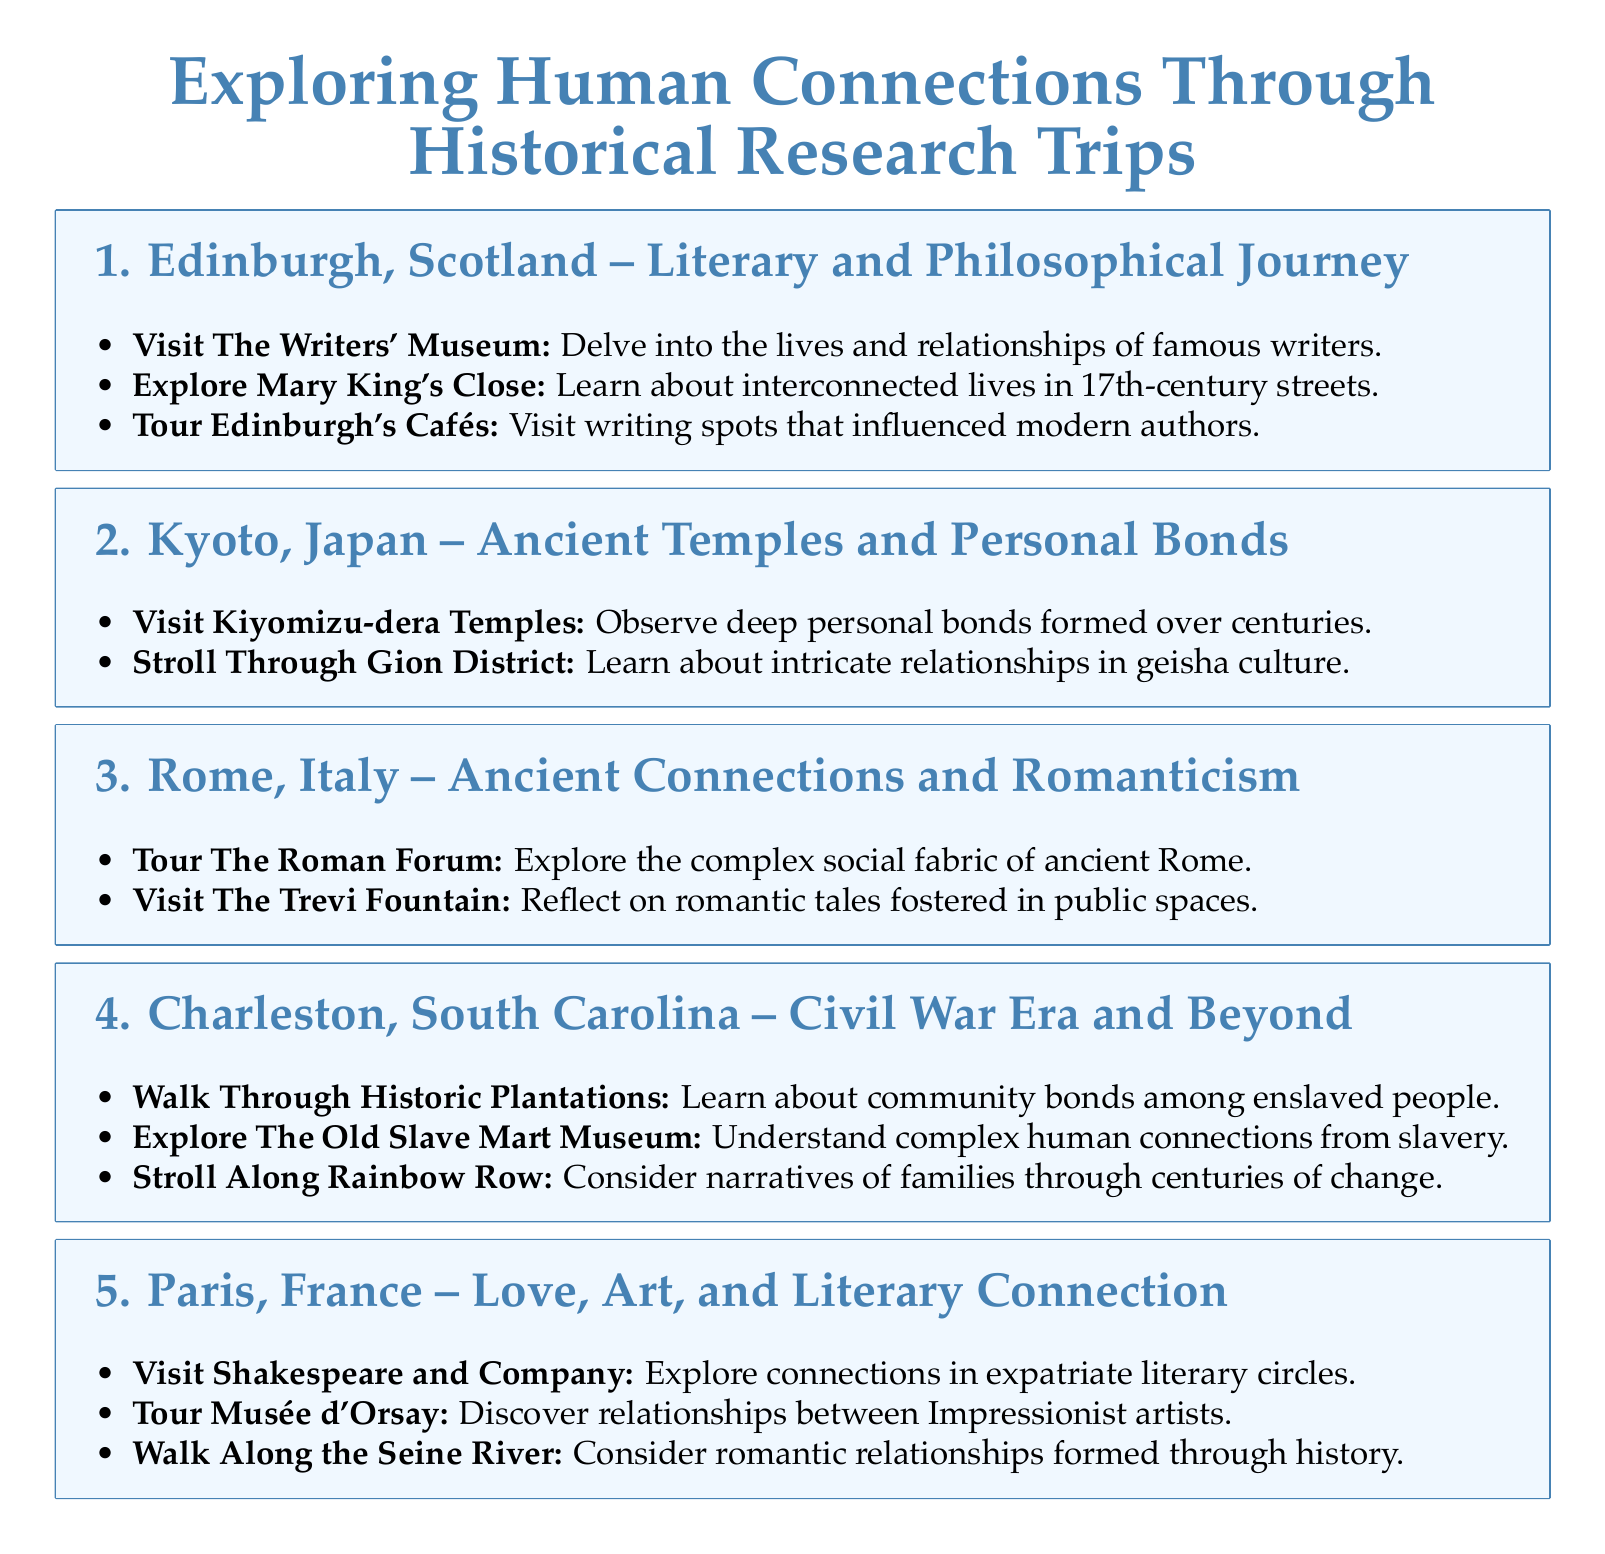What city is associated with a literary and philosophical journey? The document lists Edinburgh, Scotland as the location for a literary and philosophical journey.
Answer: Edinburgh, Scotland How many locations are covered in this itinerary? The document details five historical locations for research trips.
Answer: Five What is the first historical location mentioned in the itinerary? The first location listed is Edinburgh, Scotland.
Answer: Edinburgh, Scotland Which location features the Kiyomizu-dera Temples? The document indicates that Kiyomizu-dera Temples can be found in Kyoto, Japan.
Answer: Kyoto, Japan What type of cultural relationships are explored in the Gion District? The document suggests learning about intricate relationships in geisha culture.
Answer: Geisha culture Which historical site's touring relates to civil war era narratives? The document mentions walking through historic plantations to learn about community bonds among enslaved people.
Answer: Historic plantations What is highlighted about Rainbow Row in Charleston? The document prompts consideration of family narratives through centuries of change along Rainbow Row.
Answer: Family narratives What museum focuses on public space romantic tales in Rome? The document indicates that visiting The Trevi Fountain reflects on romantic tales fostered in public spaces.
Answer: The Trevi Fountain What does Shakespeare and Company in Paris represent? The document associates this location with exploring connections in expatriate literary circles.
Answer: Expatriate literary circles 